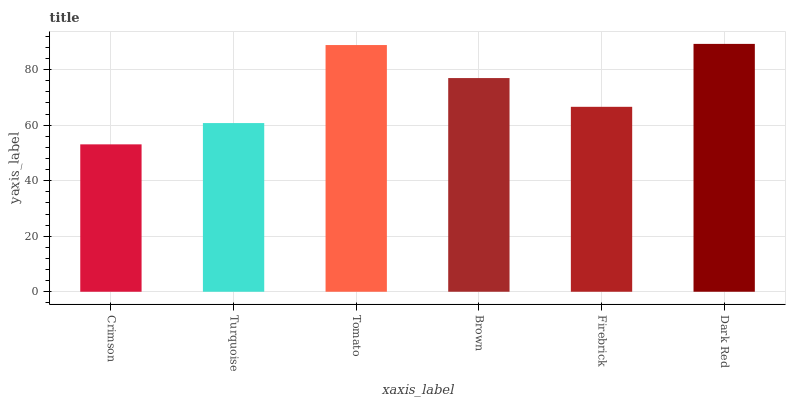Is Crimson the minimum?
Answer yes or no. Yes. Is Dark Red the maximum?
Answer yes or no. Yes. Is Turquoise the minimum?
Answer yes or no. No. Is Turquoise the maximum?
Answer yes or no. No. Is Turquoise greater than Crimson?
Answer yes or no. Yes. Is Crimson less than Turquoise?
Answer yes or no. Yes. Is Crimson greater than Turquoise?
Answer yes or no. No. Is Turquoise less than Crimson?
Answer yes or no. No. Is Brown the high median?
Answer yes or no. Yes. Is Firebrick the low median?
Answer yes or no. Yes. Is Dark Red the high median?
Answer yes or no. No. Is Dark Red the low median?
Answer yes or no. No. 